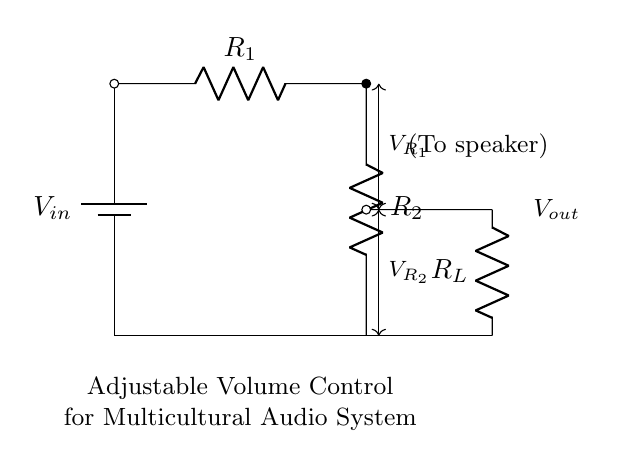What is the input voltage indicated on the circuit? The input voltage is labeled as V_in, which represents the voltage supplied to the circuit. This information is explicit in the diagram, indicated next to the battery symbol.
Answer: V_in What are the resistances in the circuit? The circuit contains two resistors labeled R_1 and R_2. These are key components of the voltage divider, providing the necessary resistance to create adjustable voltage output.
Answer: R_1 and R_2 What do the arrows with "V" symbols indicate? The arrows labeled V_R1 and V_R2 indicate the voltage drops across resistors R_1 and R_2, respectively. This shows how the input voltage is divided between these resistors in the circuit.
Answer: Voltage drops What would happen if R_2 is increased? If R_2 is increased, the output voltage V_out would increase. This is because a larger resistance will create a larger voltage drop across R_2, given the voltage divider rule.
Answer: V_out increases How is the output voltage related to V_in? The output voltage V_out is calculated using the voltage divider formula, which states V_out = V_in * (R_2 / (R_1 + R_2)). This tells us how V_out changes with the values of the resistors and the input voltage.
Answer: V_out = V_in * (R_2 / (R_1 + R_2)) What is the purpose of resistor R_L? Resistor R_L represents the load connected to the output of the voltage divider. It simulates the device (like a speaker) that consumes the output voltage from the circuit.
Answer: Load resistor 